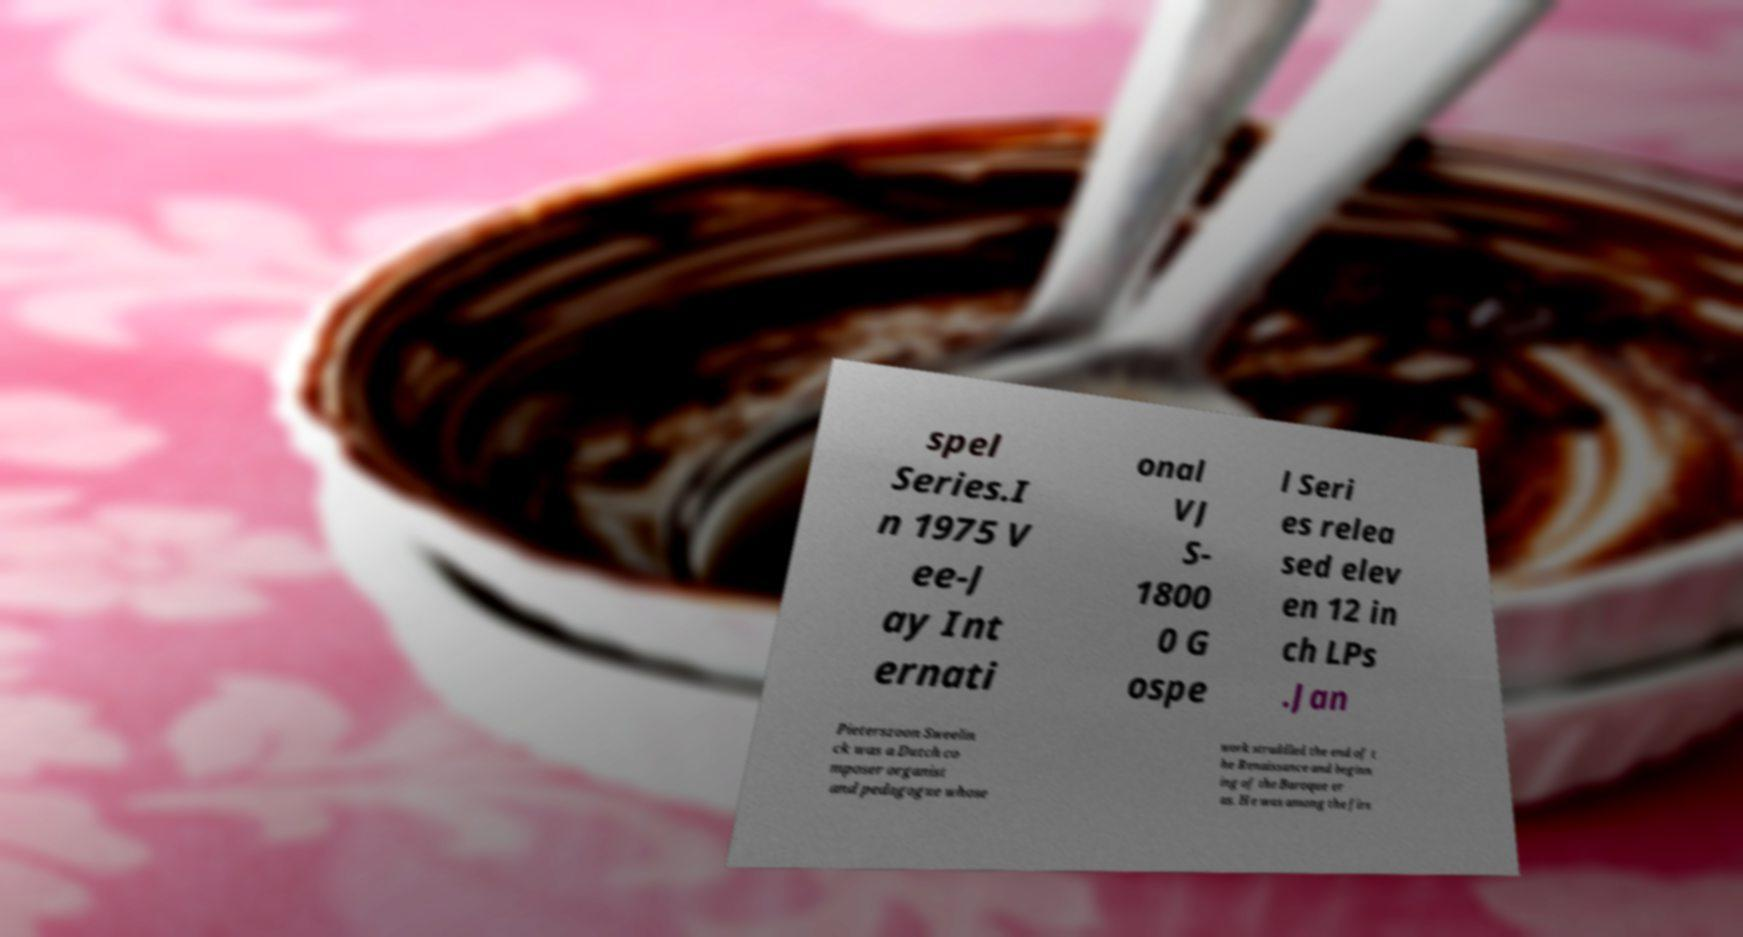Could you assist in decoding the text presented in this image and type it out clearly? spel Series.I n 1975 V ee-J ay Int ernati onal VJ S- 1800 0 G ospe l Seri es relea sed elev en 12 in ch LPs .Jan Pieterszoon Sweelin ck was a Dutch co mposer organist and pedagogue whose work straddled the end of t he Renaissance and beginn ing of the Baroque er as. He was among the firs 